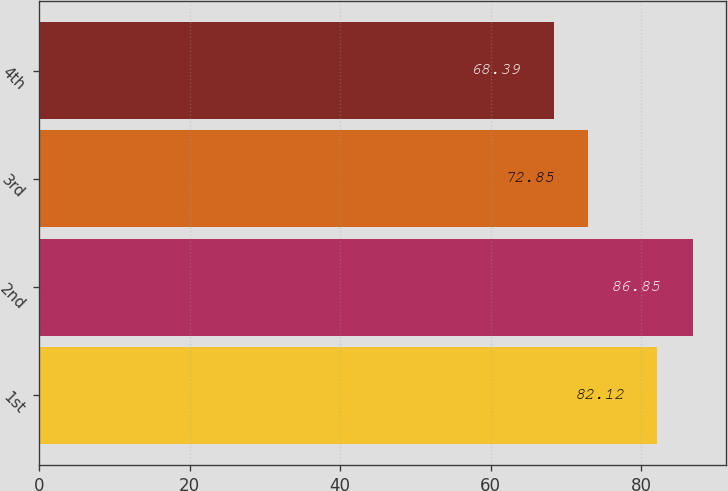<chart> <loc_0><loc_0><loc_500><loc_500><bar_chart><fcel>1st<fcel>2nd<fcel>3rd<fcel>4th<nl><fcel>82.12<fcel>86.85<fcel>72.85<fcel>68.39<nl></chart> 